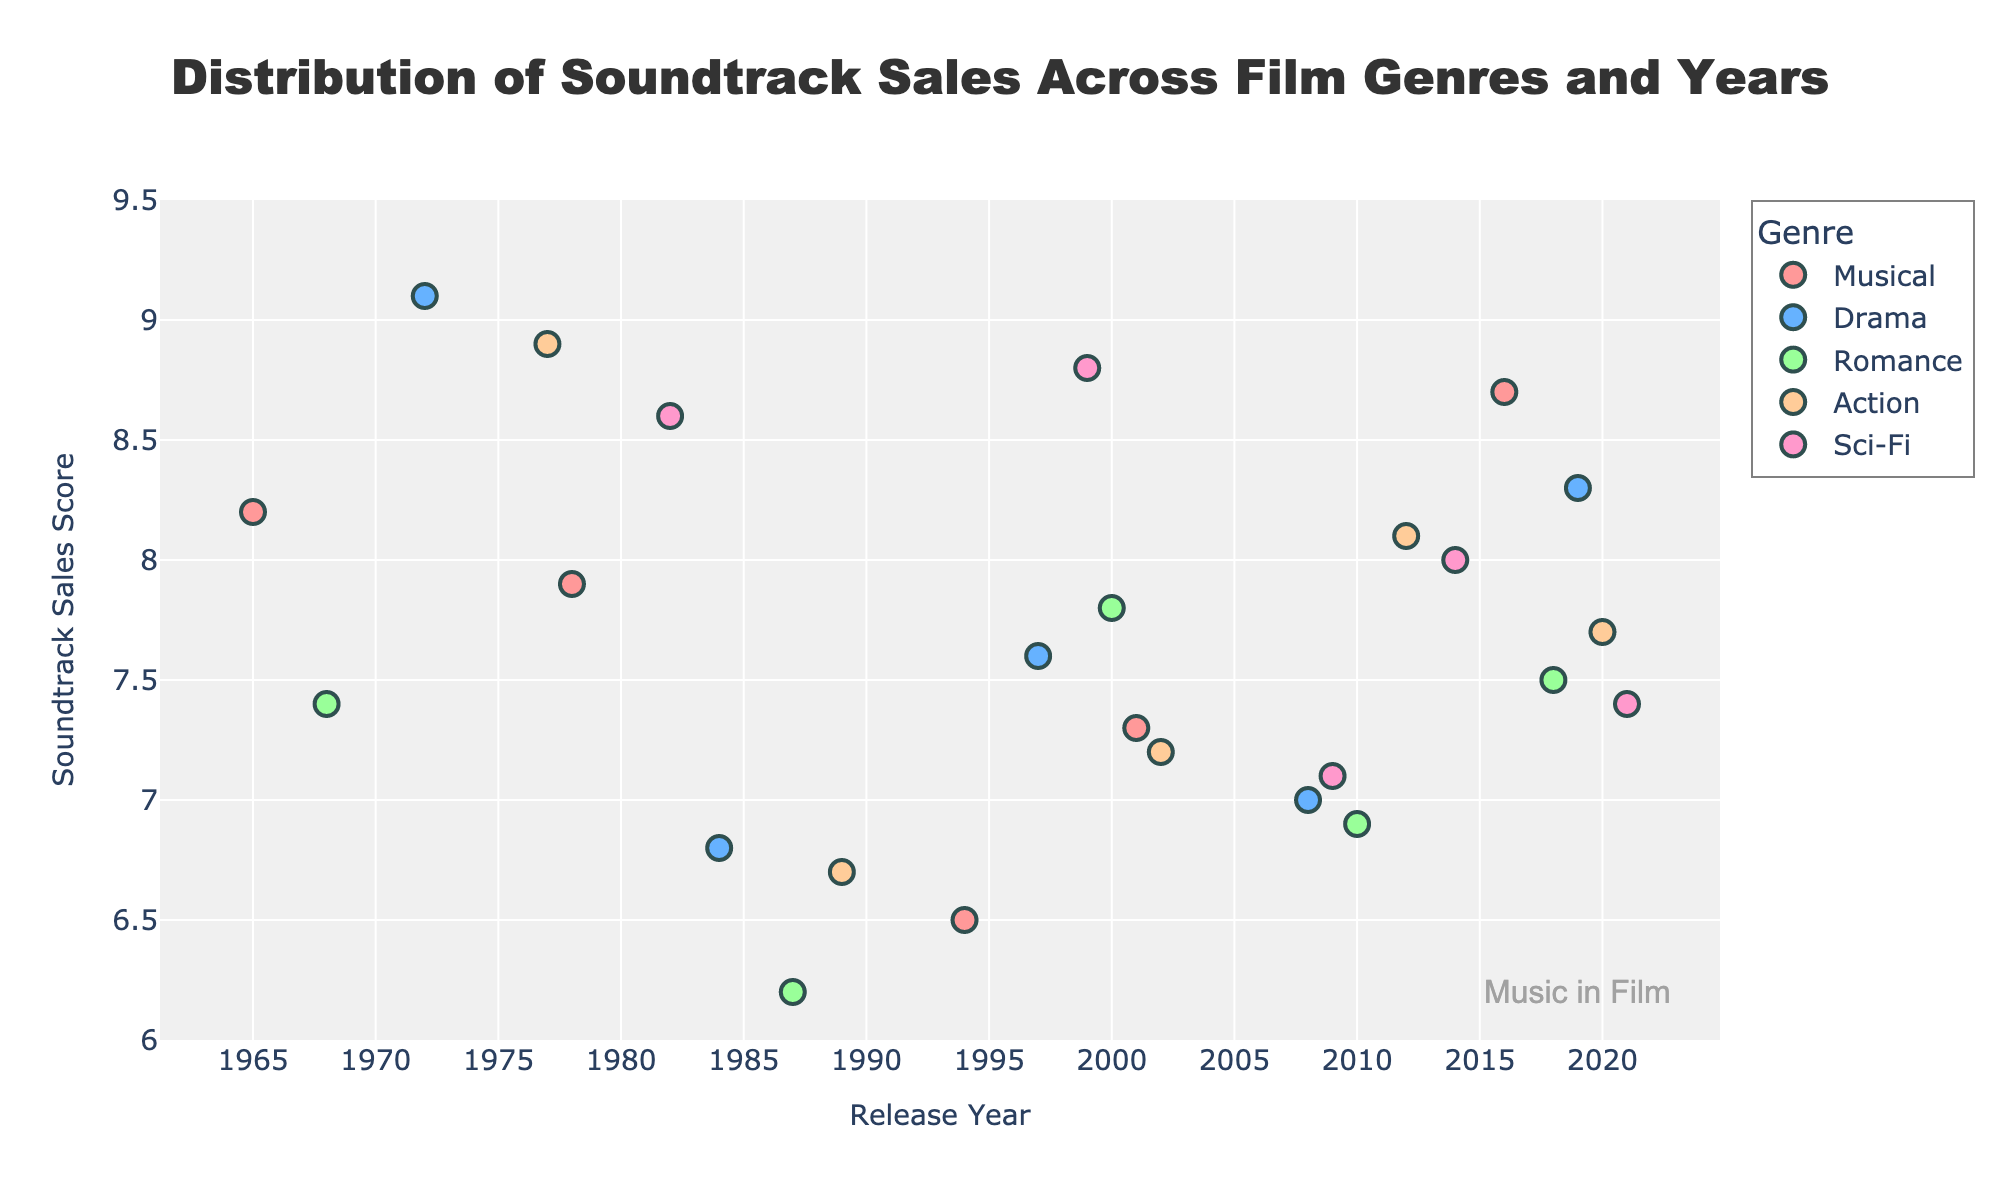What is the title of the plot? The title of the plot is displayed prominently at the top of the figure. It summarizes the main topic of the graph.
Answer: Distribution of Soundtrack Sales Across Film Genres and Years What is the range of the y-axis? The y-axis labels indicate the vertical range covered by the plot. By examining the y-axis, we can see the lowest and highest values.
Answer: 6 to 9.5 Which genre has the highest soundtrack sales score and in which year was this observed? By examining the highest point on the y-axis and cross-referencing with the genre and year, we can identify the genre and year with the highest soundtrack sales score.
Answer: Drama in 1972 How many data points are there for the genre "Romance"? By counting the number of markers associated with the "Romance" genre in the plot, we can determine the number of data points.
Answer: 5 Which genre has the lowest soundtrack sales score, and what is that score? The lowest point on the y-axis will indicate the lowest score. By checking the corresponding genre, we can identify it.
Answer: Romance, 6.2 What is the average soundtrack sales score across all genres for the year 2000? First, locate the year 2000 on the x-axis, then find all points (scores) corresponding to that year and calculate their average. The score for 2000 is available in the Romance genre.
Answer: 7.8 Among the listed genres and years, which one showed the most improvement in soundtrack sales score over time, starting from the earliest to the latest data points? By comparing the earliest and the latest scores within each genre, we can determine the genre with the highest positive change in score. For example, examining Sci-Fi: The earliest score in 1982 is 8.6, and the latest in 2021 is 7.4, showing no positive trend. The most improvement can be noted in "Musical" from 1965 (8.2) to 2016 (8.7).
Answer: Musical Compare the soundtrack sales scores of the musical genre between the years 1965 and 2016. How much did it increase or decrease? Identify the soundtrack sales score for the musical genre in 1965 and 2016. Then, compute the difference between the scores to see the increase or decrease.
Answer: Increased by 0.5 (8.7 - 8.2) Between 1984 and 2008, how did the soundtrack sales scores of Drama change? Locate the data points for Drama in 1984 (6.8) and 2008 (7.0) and compute the difference between these points to assess the change.
Answer: Increased by 0.2 (7.0 - 6.8) How does the variability in soundtrack sales scores for Sci-Fi compare to Action across the years? To assess variability, look at the spread of data points for Sci-Fi and Action. Sci-Fi varies from 7.1 to 8.8, while Action ranges from 6.7 to 8.9.
Answer: Similar variability (Sci-Fi: 1.7, Action: 2.2) 